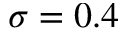<formula> <loc_0><loc_0><loc_500><loc_500>\sigma = 0 . 4</formula> 